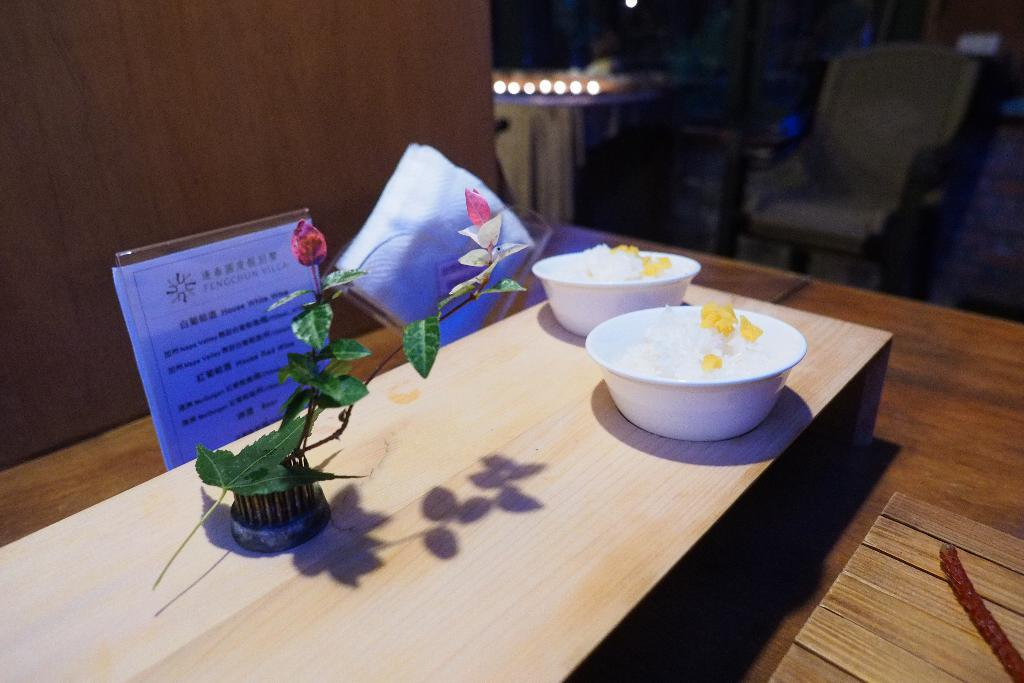What piece of furniture is present in the image? There is a table in the image. How many bowls are on the table? There are two bowls on the table. What can be seen in the middle of the image? There is a plant in the middle of the image. Where is the chair located in the image? There is a chair in the top right side of the image. What type of sock is hanging from the wire in the image? There is no sock or wire present in the image. What is the slope of the hill in the image? There is no hill or slope present in the image. 